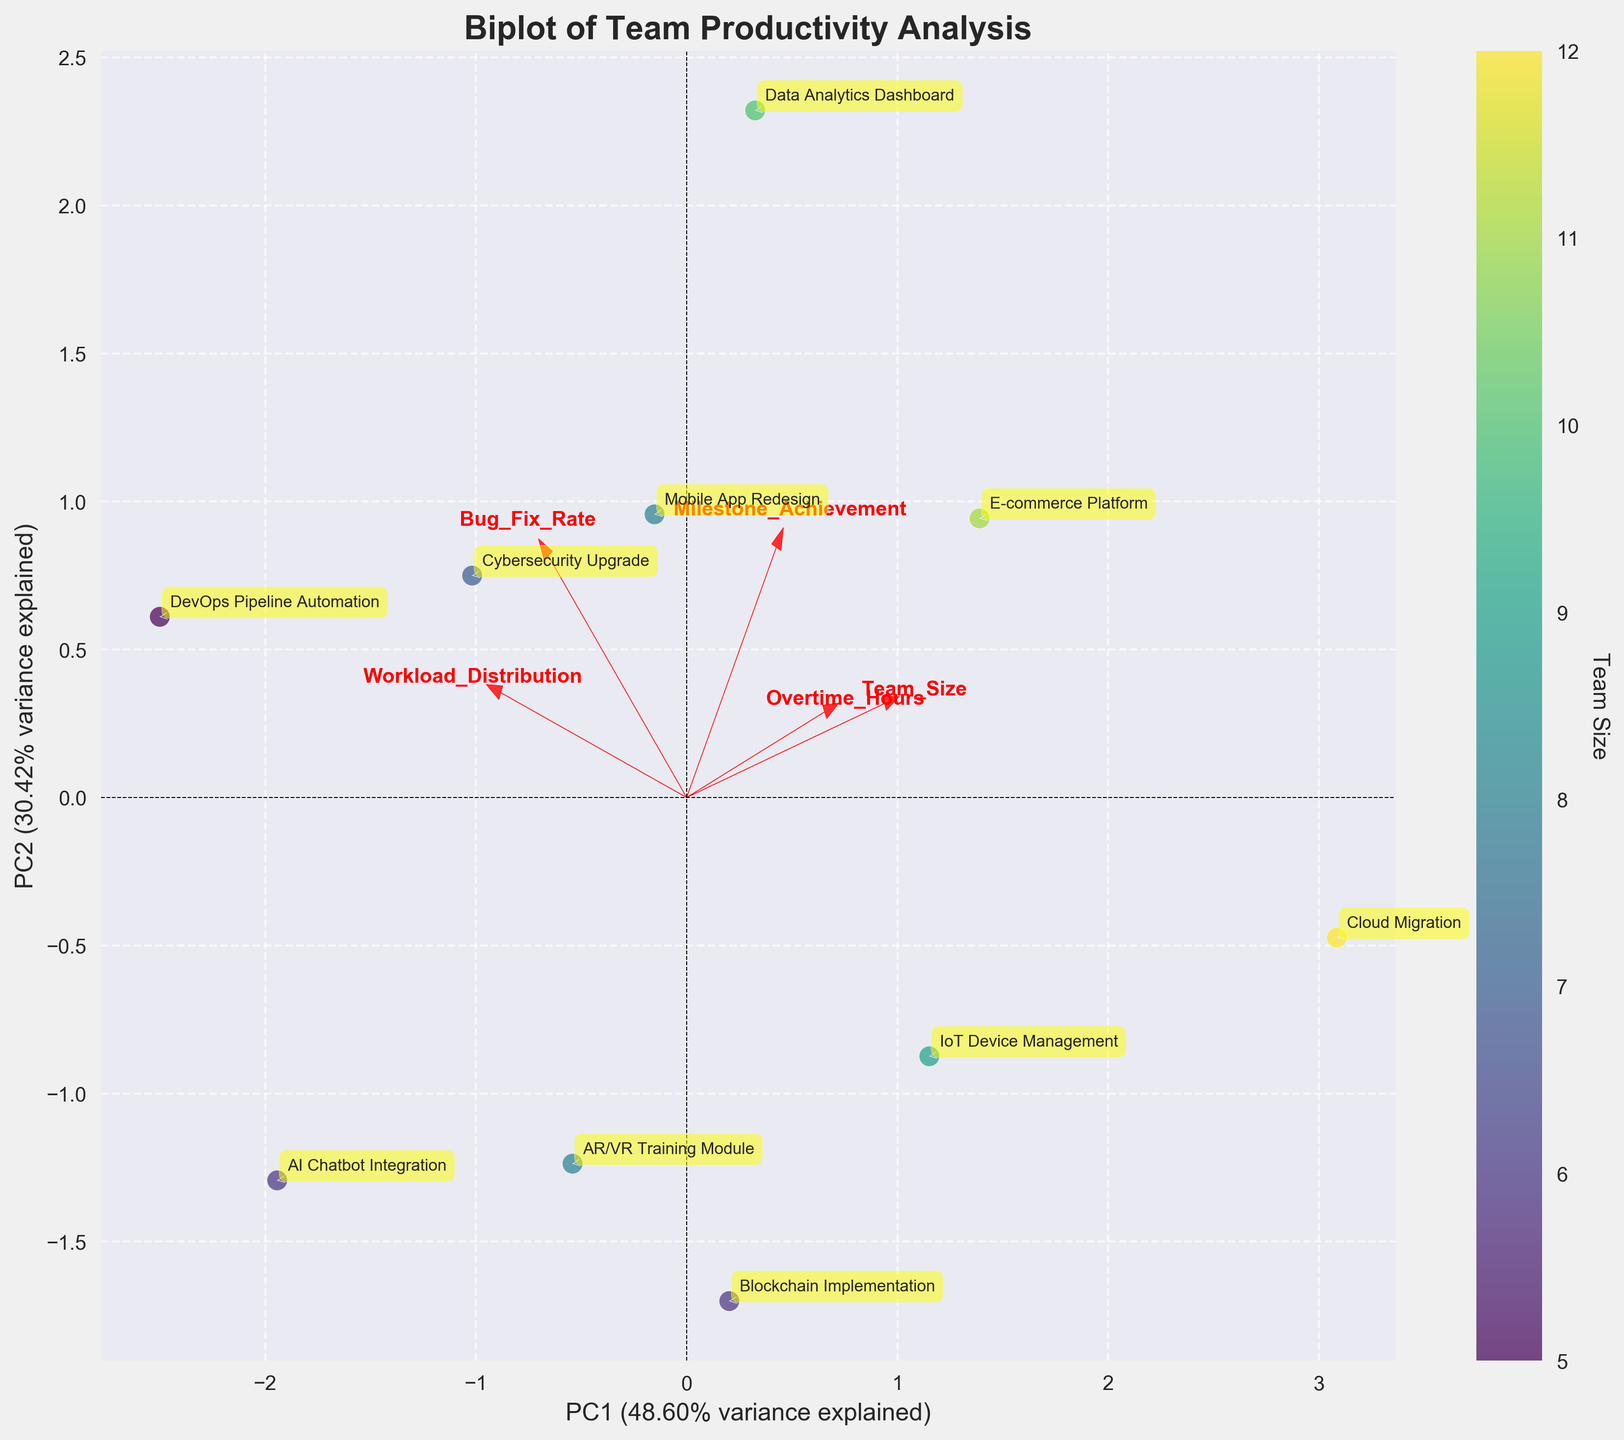What is the title of the plot? The title is displayed at the top of the plot and provides a summary of what the visualization represents. In this case, it mentions the biplot of team productivity analysis.
Answer: Biplot of Team Productivity Analysis How many team sizes are represented in the plot? Team sizes are denoted by the color of the points and can be identified using the color bar on the right side of the plot. We observe that each point corresponds to a different project since there are labels for each, indicating there are 10 different team sizes.
Answer: 10 Which project has the lowest Milestone Achievement score? To determine this, we need to look for the points that are located furthest left on the Milestone Achievement axis (PC2). The project labels near these points will give us the answer.
Answer: AI Chatbot Integration Does the Cybersecurity Upgrade project have a high or low Bug Fix Rate based on the plot's loading vectors? Bug Fix Rate is indicated by one of the red arrows (loading vectors). If the Cybersecurity Upgrade point is close to the direction of the Bug Fix Rate arrow, it indicates a high rate. Based on the placement near the arrow, it suggests high.
Answer: High Which two projects appear the closest together on the plot, indicating similar PCA scores? By visually examining the distances between points on the plot, we can determine which projects are closest. The Mobile App Redesign and AR/VR Training Module appear very close to each other.
Answer: Mobile App Redesign and AR/VR Training Module What percentage of variance is explained by the first principal component (PC1)? The percentage of variance explained by PC1 is indicated on the x-axis label of the plot. It provides a quantitative measure of how much of the variability in the data is captured by PC1.
Answer: ~44% How does the DevOps Pipeline Automation project compare to others in terms of Overtime Hours based on the loading vectors? The Loading vectors help us to understand how features like Overtime Hours contribute to the data structure in the PCA space. If the DevOps point is positioned along the direction of the Overtime Hours arrow, it indicates a higher value. It seems to have less overtime than some other projects.
Answer: Lower Which features (variables) are most influential in separating the projects according to the plot? The loading vectors' lengths and directions indicate the influence of features. The longest arrows point towards the most influential features. The plot indicates that Bug Fix Rate and Workload Distribution have long arrows pointing in specific directions, making them influential.
Answer: Bug Fix Rate and Workload Distribution Which project has the highest team size? The size of the colored circle represents the team size for each project. The furthest point in the color gradient (dark purple) from the color bar indicates the largest team size. This is associated with Cloud Migration.
Answer: Cloud Migration 